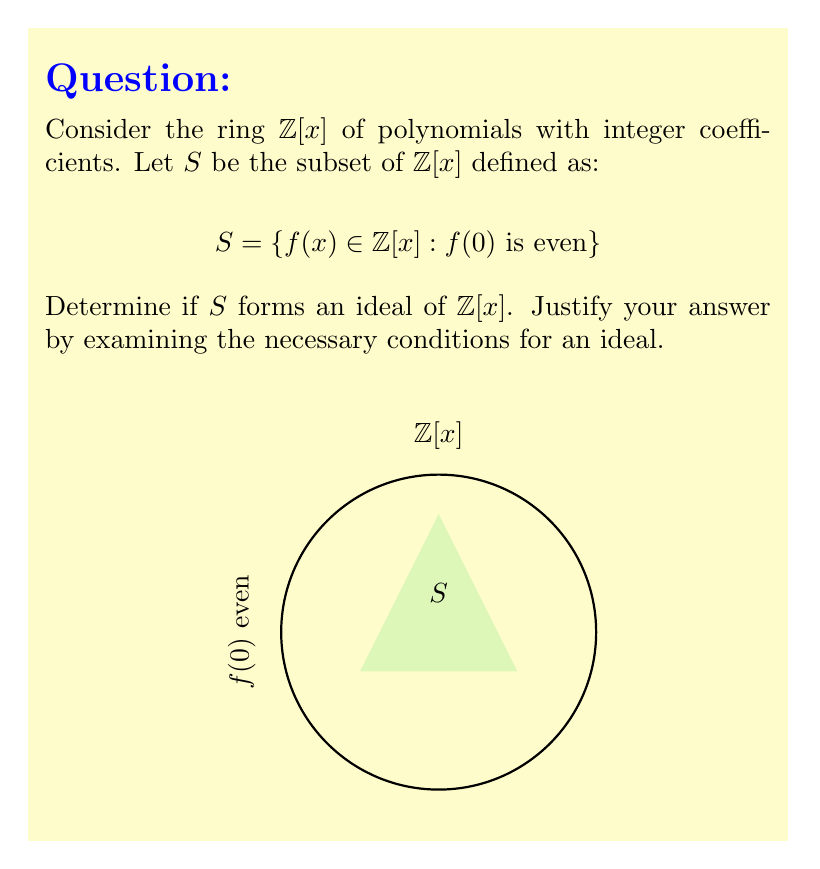Could you help me with this problem? To determine if $S$ forms an ideal of $\mathbb{Z}[x]$, we need to check three conditions:

1. Closure under addition:
Let $f(x), g(x) \in S$. Then $f(0)$ and $g(0)$ are both even.
$(f+g)(0) = f(0) + g(0)$ is the sum of two even numbers, which is even.
Therefore, $(f+g)(x) \in S$.

2. Closure under subtraction:
Let $f(x), g(x) \in S$. Then $f(0)$ and $g(0)$ are both even.
$(f-g)(0) = f(0) - g(0)$ is the difference of two even numbers, which is even.
Therefore, $(f-g)(x) \in S$.

3. Closure under multiplication by ring elements:
Let $f(x) \in S$ and $r(x) \in \mathbb{Z}[x]$.
$(rf)(0) = r(0)f(0)$
$f(0)$ is even, but $r(0)$ can be any integer.
If $r(0)$ is odd, $(rf)(0)$ will be even.
If $r(0)$ is even, $(rf)(0)$ will be even.
Therefore, $(rf)(x) \in S$ for all $r(x) \in \mathbb{Z}[x]$.

Since all three conditions are satisfied, $S$ forms an ideal of $\mathbb{Z}[x]$.
Answer: Yes, $S$ is an ideal of $\mathbb{Z}[x]$. 